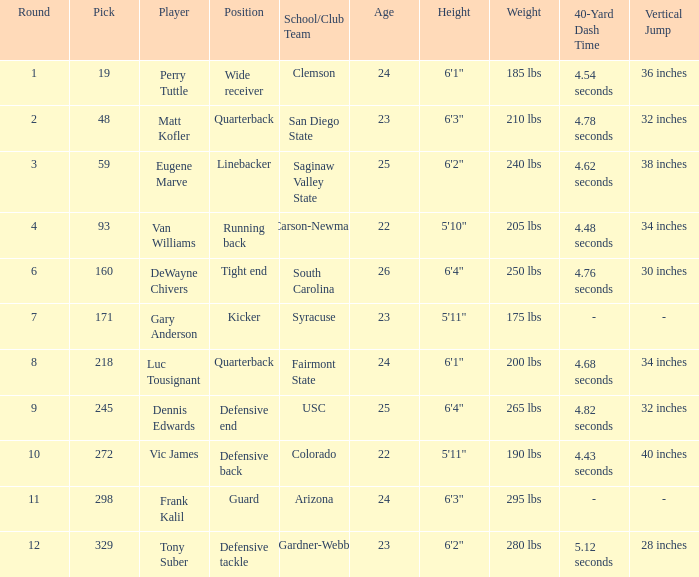Who plays linebacker? Eugene Marve. 